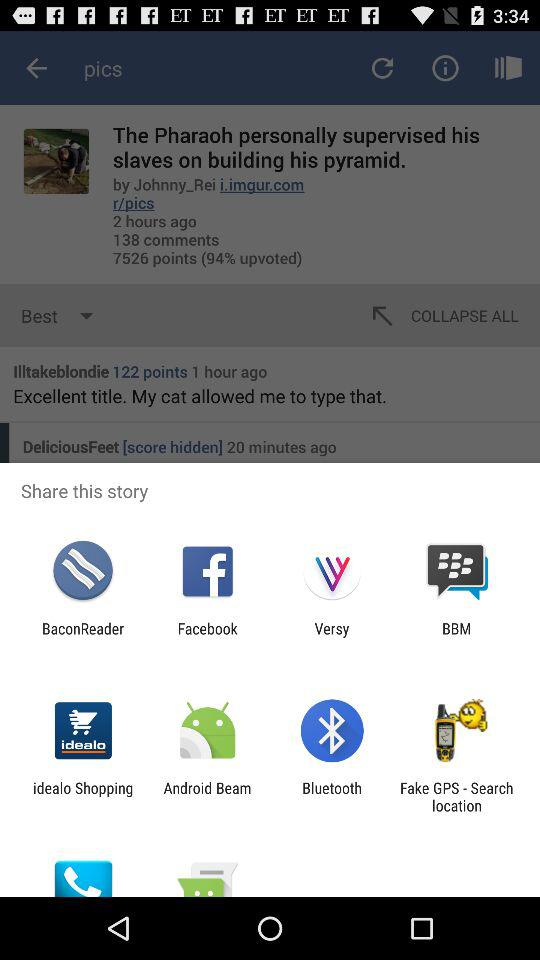How many comments does the post have?
Answer the question using a single word or phrase. 138 